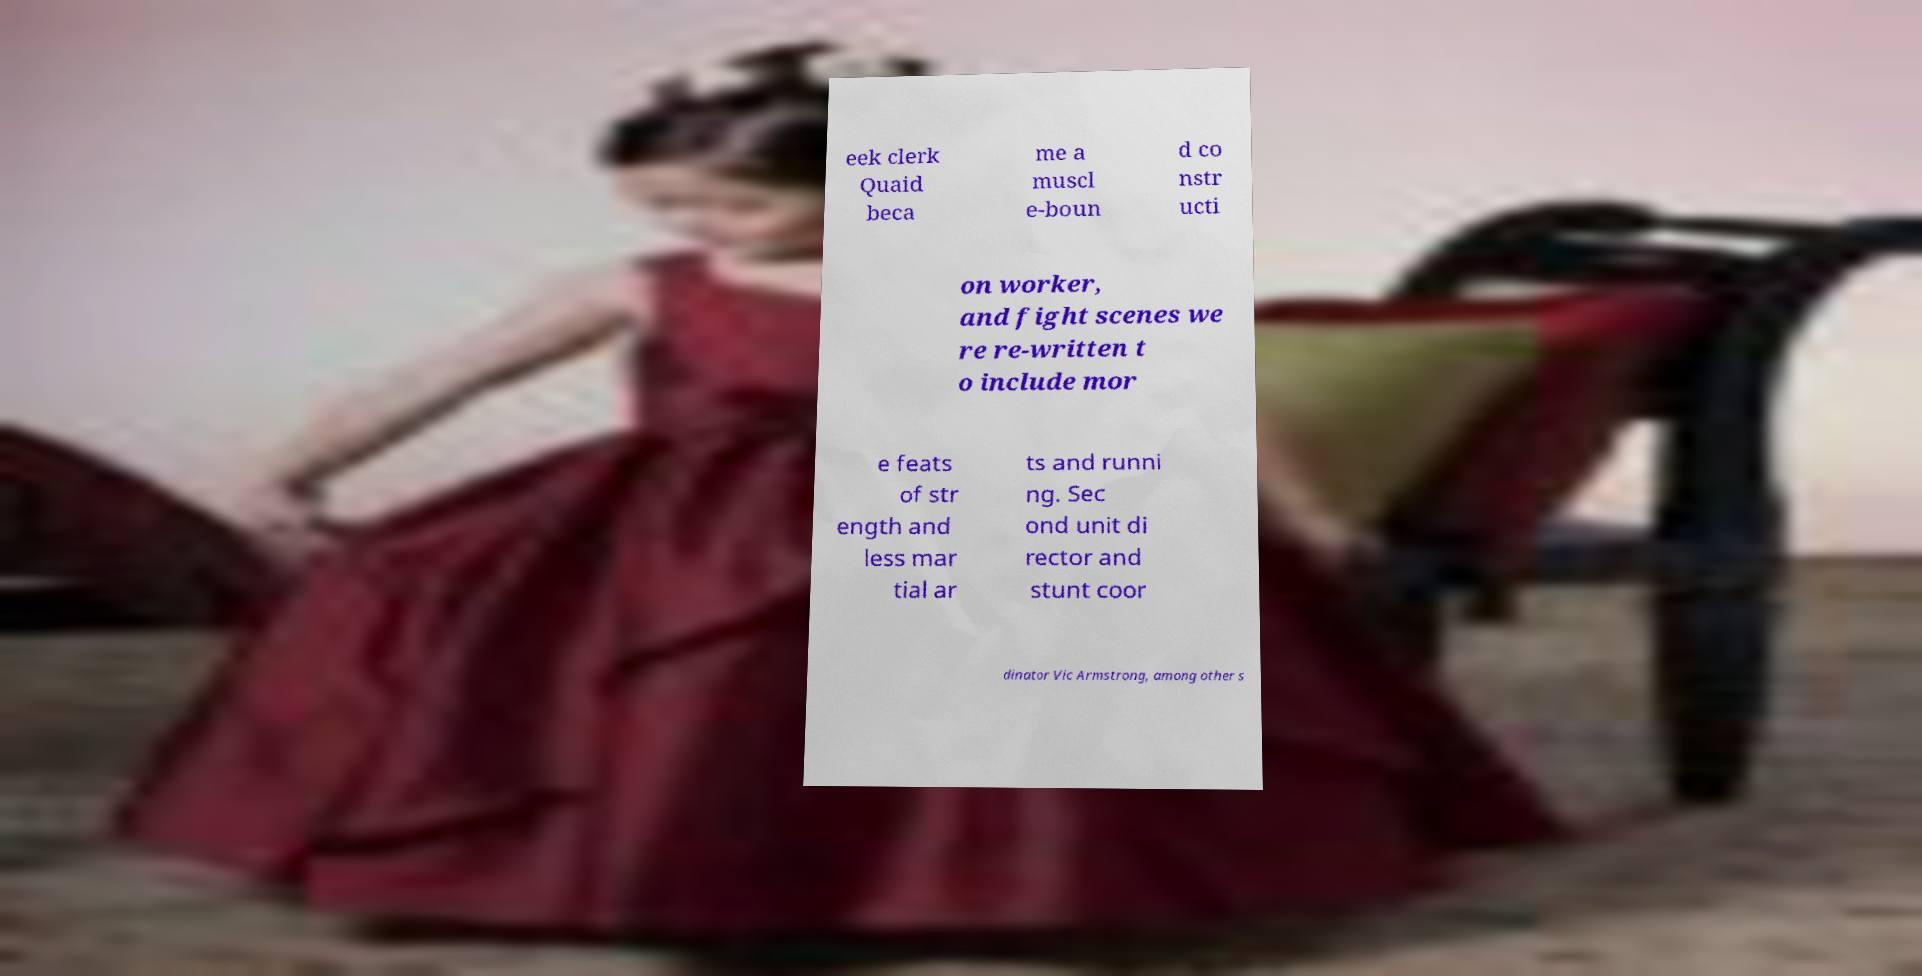Can you read and provide the text displayed in the image?This photo seems to have some interesting text. Can you extract and type it out for me? eek clerk Quaid beca me a muscl e-boun d co nstr ucti on worker, and fight scenes we re re-written t o include mor e feats of str ength and less mar tial ar ts and runni ng. Sec ond unit di rector and stunt coor dinator Vic Armstrong, among other s 